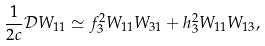Convert formula to latex. <formula><loc_0><loc_0><loc_500><loc_500>\frac { 1 } { 2 c } \mathcal { D } W _ { 1 1 } \simeq f ^ { 2 } _ { 3 } W _ { 1 1 } W _ { 3 1 } + h ^ { 2 } _ { 3 } W _ { 1 1 } W _ { 1 3 } ,</formula> 